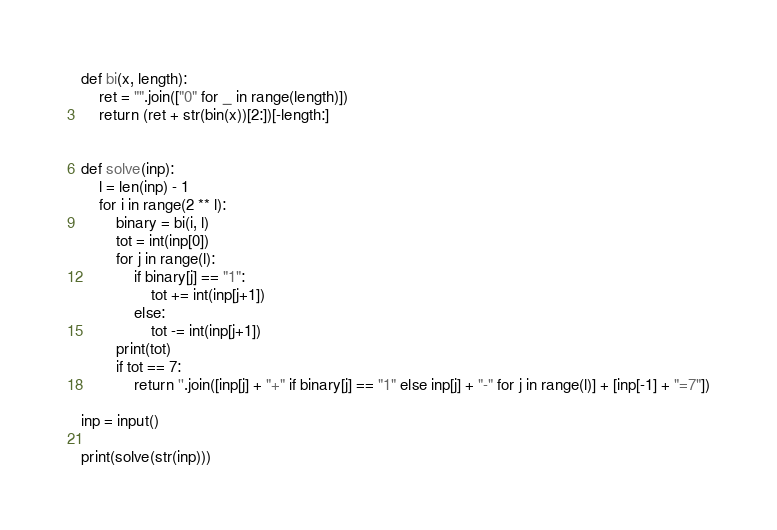<code> <loc_0><loc_0><loc_500><loc_500><_Python_>def bi(x, length):
    ret = "".join(["0" for _ in range(length)])
    return (ret + str(bin(x))[2:])[-length:]


def solve(inp):
    l = len(inp) - 1
    for i in range(2 ** l):
        binary = bi(i, l)
        tot = int(inp[0])
        for j in range(l):
            if binary[j] == "1":
                tot += int(inp[j+1])
            else:
                tot -= int(inp[j+1])
        print(tot)
        if tot == 7:
            return ''.join([inp[j] + "+" if binary[j] == "1" else inp[j] + "-" for j in range(l)] + [inp[-1] + "=7"])

inp = input()

print(solve(str(inp)))
</code> 